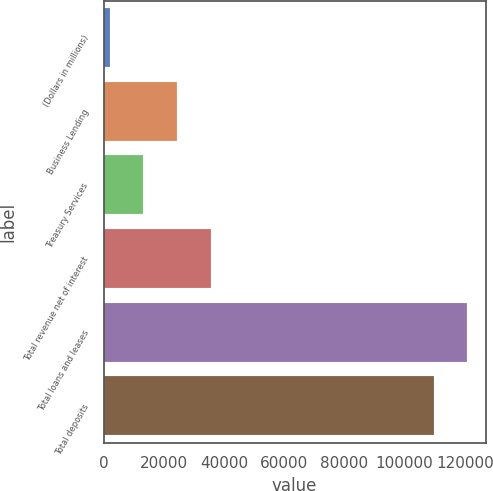<chart> <loc_0><loc_0><loc_500><loc_500><bar_chart><fcel>(Dollars in millions)<fcel>Business Lending<fcel>Treasury Services<fcel>Total revenue net of interest<fcel>Total loans and leases<fcel>Total deposits<nl><fcel>2012<fcel>24337.6<fcel>13174.8<fcel>35500.4<fcel>120867<fcel>109704<nl></chart> 